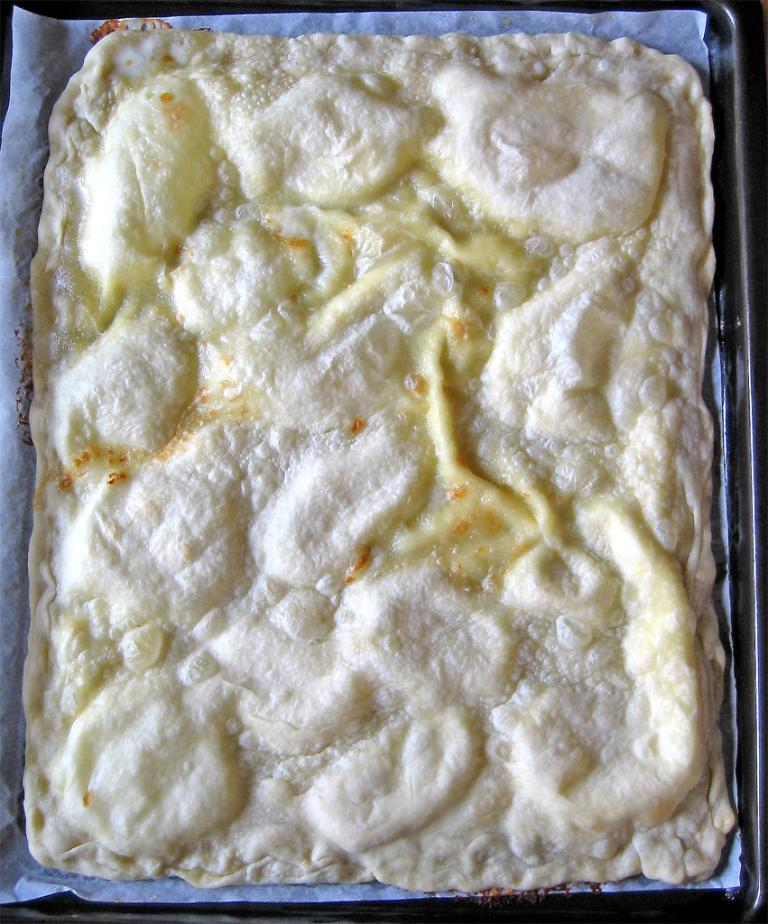What is present in the image? There are food items in a tray in the image. Can you describe the food items in the tray? Unfortunately, the specific food items cannot be determined from the provided fact. Is there any other object or item visible in the image? No additional information is provided about any other objects or items in the image. Are there any bears visible in the image? No, there are no bears present in the image. Can you tell me how much the food items in the tray cost? The provided fact does not mention any prices or currency, so it is impossible to determine the cost of the food items in the image. 